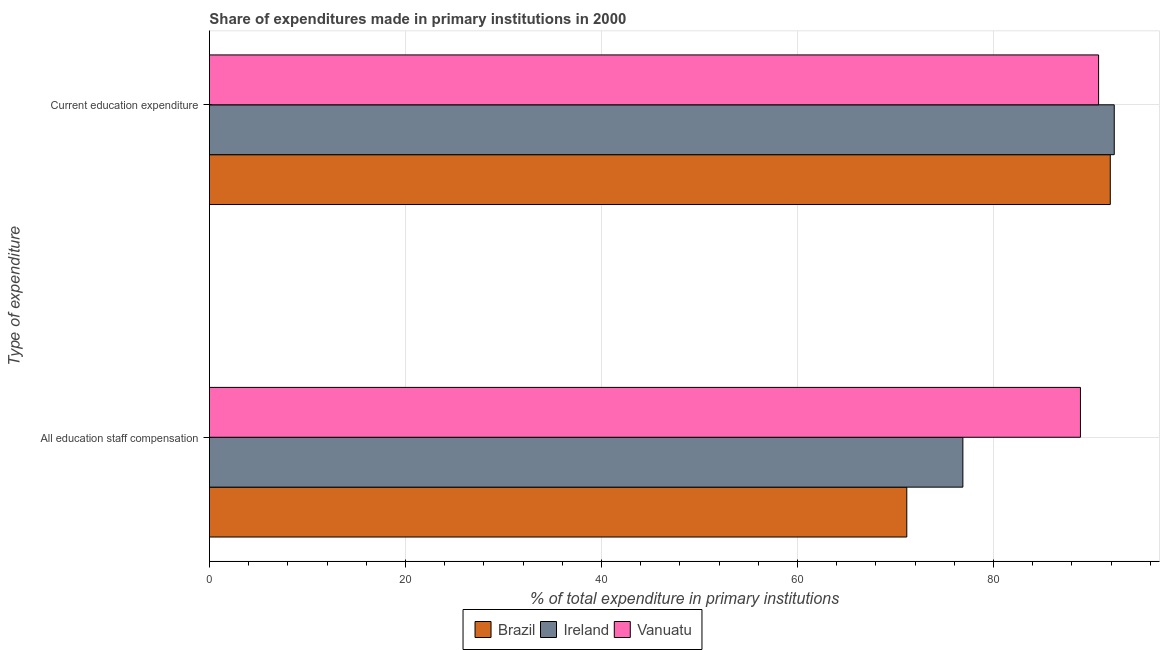How many groups of bars are there?
Ensure brevity in your answer.  2. How many bars are there on the 2nd tick from the top?
Your answer should be very brief. 3. How many bars are there on the 2nd tick from the bottom?
Offer a terse response. 3. What is the label of the 1st group of bars from the top?
Provide a short and direct response. Current education expenditure. What is the expenditure in staff compensation in Vanuatu?
Keep it short and to the point. 88.87. Across all countries, what is the maximum expenditure in education?
Offer a terse response. 92.32. Across all countries, what is the minimum expenditure in education?
Your answer should be compact. 90.72. In which country was the expenditure in staff compensation maximum?
Keep it short and to the point. Vanuatu. In which country was the expenditure in education minimum?
Your answer should be compact. Vanuatu. What is the total expenditure in education in the graph?
Keep it short and to the point. 274.96. What is the difference between the expenditure in education in Ireland and that in Vanuatu?
Make the answer very short. 1.6. What is the difference between the expenditure in staff compensation in Brazil and the expenditure in education in Vanuatu?
Your answer should be very brief. -19.57. What is the average expenditure in education per country?
Your answer should be very brief. 91.65. What is the difference between the expenditure in staff compensation and expenditure in education in Ireland?
Keep it short and to the point. -15.45. What is the ratio of the expenditure in staff compensation in Ireland to that in Brazil?
Your response must be concise. 1.08. What does the 2nd bar from the top in All education staff compensation represents?
Keep it short and to the point. Ireland. What does the 2nd bar from the bottom in Current education expenditure represents?
Offer a very short reply. Ireland. How many bars are there?
Your response must be concise. 6. Are all the bars in the graph horizontal?
Provide a short and direct response. Yes. How many countries are there in the graph?
Offer a very short reply. 3. What is the difference between two consecutive major ticks on the X-axis?
Your answer should be very brief. 20. Are the values on the major ticks of X-axis written in scientific E-notation?
Keep it short and to the point. No. Does the graph contain grids?
Make the answer very short. Yes. Where does the legend appear in the graph?
Offer a very short reply. Bottom center. How are the legend labels stacked?
Your answer should be compact. Horizontal. What is the title of the graph?
Provide a short and direct response. Share of expenditures made in primary institutions in 2000. What is the label or title of the X-axis?
Provide a succinct answer. % of total expenditure in primary institutions. What is the label or title of the Y-axis?
Offer a terse response. Type of expenditure. What is the % of total expenditure in primary institutions in Brazil in All education staff compensation?
Offer a terse response. 71.15. What is the % of total expenditure in primary institutions of Ireland in All education staff compensation?
Offer a very short reply. 76.88. What is the % of total expenditure in primary institutions of Vanuatu in All education staff compensation?
Your answer should be very brief. 88.87. What is the % of total expenditure in primary institutions of Brazil in Current education expenditure?
Ensure brevity in your answer.  91.92. What is the % of total expenditure in primary institutions in Ireland in Current education expenditure?
Provide a succinct answer. 92.32. What is the % of total expenditure in primary institutions in Vanuatu in Current education expenditure?
Give a very brief answer. 90.72. Across all Type of expenditure, what is the maximum % of total expenditure in primary institutions of Brazil?
Provide a succinct answer. 91.92. Across all Type of expenditure, what is the maximum % of total expenditure in primary institutions in Ireland?
Ensure brevity in your answer.  92.32. Across all Type of expenditure, what is the maximum % of total expenditure in primary institutions of Vanuatu?
Your response must be concise. 90.72. Across all Type of expenditure, what is the minimum % of total expenditure in primary institutions of Brazil?
Provide a succinct answer. 71.15. Across all Type of expenditure, what is the minimum % of total expenditure in primary institutions in Ireland?
Offer a very short reply. 76.88. Across all Type of expenditure, what is the minimum % of total expenditure in primary institutions of Vanuatu?
Keep it short and to the point. 88.87. What is the total % of total expenditure in primary institutions in Brazil in the graph?
Your answer should be compact. 163.07. What is the total % of total expenditure in primary institutions of Ireland in the graph?
Make the answer very short. 169.2. What is the total % of total expenditure in primary institutions in Vanuatu in the graph?
Make the answer very short. 179.6. What is the difference between the % of total expenditure in primary institutions of Brazil in All education staff compensation and that in Current education expenditure?
Your answer should be very brief. -20.76. What is the difference between the % of total expenditure in primary institutions in Ireland in All education staff compensation and that in Current education expenditure?
Your answer should be very brief. -15.45. What is the difference between the % of total expenditure in primary institutions in Vanuatu in All education staff compensation and that in Current education expenditure?
Your answer should be very brief. -1.85. What is the difference between the % of total expenditure in primary institutions of Brazil in All education staff compensation and the % of total expenditure in primary institutions of Ireland in Current education expenditure?
Provide a short and direct response. -21.17. What is the difference between the % of total expenditure in primary institutions in Brazil in All education staff compensation and the % of total expenditure in primary institutions in Vanuatu in Current education expenditure?
Give a very brief answer. -19.57. What is the difference between the % of total expenditure in primary institutions of Ireland in All education staff compensation and the % of total expenditure in primary institutions of Vanuatu in Current education expenditure?
Ensure brevity in your answer.  -13.85. What is the average % of total expenditure in primary institutions of Brazil per Type of expenditure?
Offer a very short reply. 81.54. What is the average % of total expenditure in primary institutions in Ireland per Type of expenditure?
Provide a short and direct response. 84.6. What is the average % of total expenditure in primary institutions in Vanuatu per Type of expenditure?
Ensure brevity in your answer.  89.8. What is the difference between the % of total expenditure in primary institutions of Brazil and % of total expenditure in primary institutions of Ireland in All education staff compensation?
Give a very brief answer. -5.72. What is the difference between the % of total expenditure in primary institutions in Brazil and % of total expenditure in primary institutions in Vanuatu in All education staff compensation?
Make the answer very short. -17.72. What is the difference between the % of total expenditure in primary institutions of Ireland and % of total expenditure in primary institutions of Vanuatu in All education staff compensation?
Ensure brevity in your answer.  -12. What is the difference between the % of total expenditure in primary institutions of Brazil and % of total expenditure in primary institutions of Ireland in Current education expenditure?
Give a very brief answer. -0.4. What is the difference between the % of total expenditure in primary institutions in Brazil and % of total expenditure in primary institutions in Vanuatu in Current education expenditure?
Make the answer very short. 1.19. What is the difference between the % of total expenditure in primary institutions in Ireland and % of total expenditure in primary institutions in Vanuatu in Current education expenditure?
Your answer should be compact. 1.6. What is the ratio of the % of total expenditure in primary institutions in Brazil in All education staff compensation to that in Current education expenditure?
Your answer should be very brief. 0.77. What is the ratio of the % of total expenditure in primary institutions of Ireland in All education staff compensation to that in Current education expenditure?
Your response must be concise. 0.83. What is the ratio of the % of total expenditure in primary institutions in Vanuatu in All education staff compensation to that in Current education expenditure?
Your answer should be very brief. 0.98. What is the difference between the highest and the second highest % of total expenditure in primary institutions in Brazil?
Offer a terse response. 20.76. What is the difference between the highest and the second highest % of total expenditure in primary institutions in Ireland?
Your answer should be compact. 15.45. What is the difference between the highest and the second highest % of total expenditure in primary institutions of Vanuatu?
Your answer should be very brief. 1.85. What is the difference between the highest and the lowest % of total expenditure in primary institutions of Brazil?
Give a very brief answer. 20.76. What is the difference between the highest and the lowest % of total expenditure in primary institutions of Ireland?
Make the answer very short. 15.45. What is the difference between the highest and the lowest % of total expenditure in primary institutions in Vanuatu?
Your response must be concise. 1.85. 